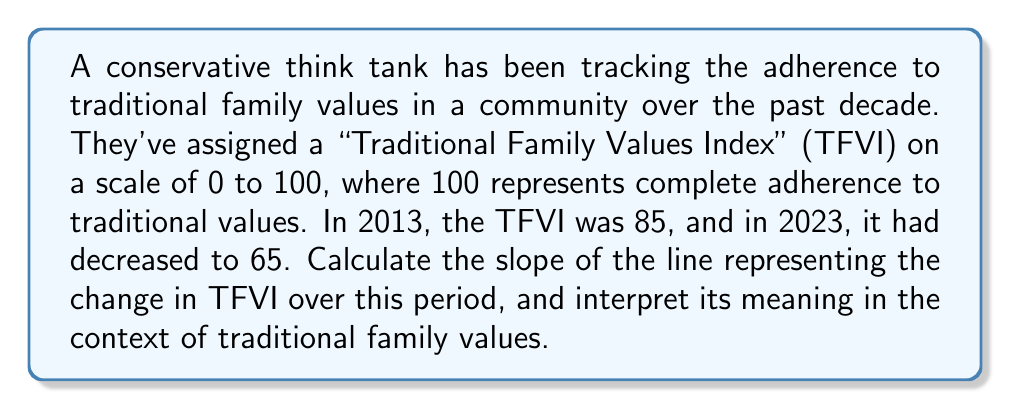Help me with this question. To calculate the slope of the line representing the change in Traditional Family Values Index (TFVI) over time, we'll use the slope formula:

$$m = \frac{y_2 - y_1}{x_2 - x_1}$$

Where:
$m$ = slope
$(x_1, y_1)$ = first point (2013, 85)
$(x_2, y_2)$ = second point (2023, 65)

Step 1: Identify the coordinates
$x_1 = 2013$, $y_1 = 85$
$x_2 = 2023$, $y_2 = 65$

Step 2: Apply the slope formula
$$m = \frac{65 - 85}{2023 - 2013} = \frac{-20}{10} = -2$$

Step 3: Interpret the result
The slope is -2, which means that for each year that passes, the TFVI decreases by 2 points on average. This negative slope indicates a decline in adherence to traditional family values over the given period.

[asy]
unitsize(10mm);
draw((-1,0)--(11,0),arrow=Arrow(TeXHead));
draw((0,-1)--(0,11),arrow=Arrow(TeXHead));
for(int i=0; i<=10; ++i) {
  draw((i,-0.1)--(i,0.1));
  label(format("%d",2013+i),(i,-0.5),S);
}
for(int i=0; i<=10; ++i) {
  draw((-0.1,i)--(0.1,i));
  label(format("%d",60+5*i),(-0.5,i),W);
}
draw((0,8.5)--(10,6.5),blue);
dot((0,8.5));
dot((10,6.5));
label("(2013, 85)",(0,8.5),NW);
label("(2023, 65)",(10,6.5),SE);
label("TFVI",(0,11),N);
label("Year",(11,0),E);
[/asy]
Answer: The slope of the line representing the change in Traditional Family Values Index over time is $-2$ TFVI points per year, indicating a decline in adherence to traditional family values in the community over the past decade. 